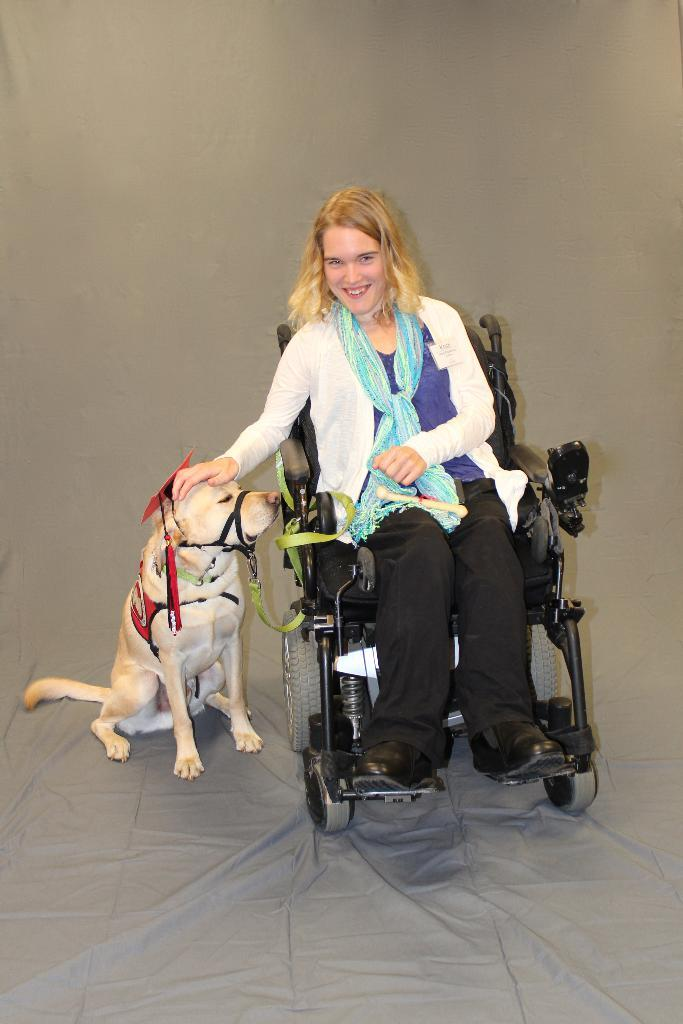Who is the main subject in the image? There is a woman in the image. What is the woman doing in the image? The woman is smiling and sitting on a wheelchair. What is the woman doing with her hand in the image? The woman has her hand on the dog's head. What can be seen beside the woman in the image? There is a dog beside the woman. How would you describe the background of the image? The background of the image is in gray color. What type of prose is the woman reading to the dog in the image? There is no prose or reading activity present in the image. How many toes does the dog have in the image? The image does not show the dog's toes, so it cannot be determined from the image. 